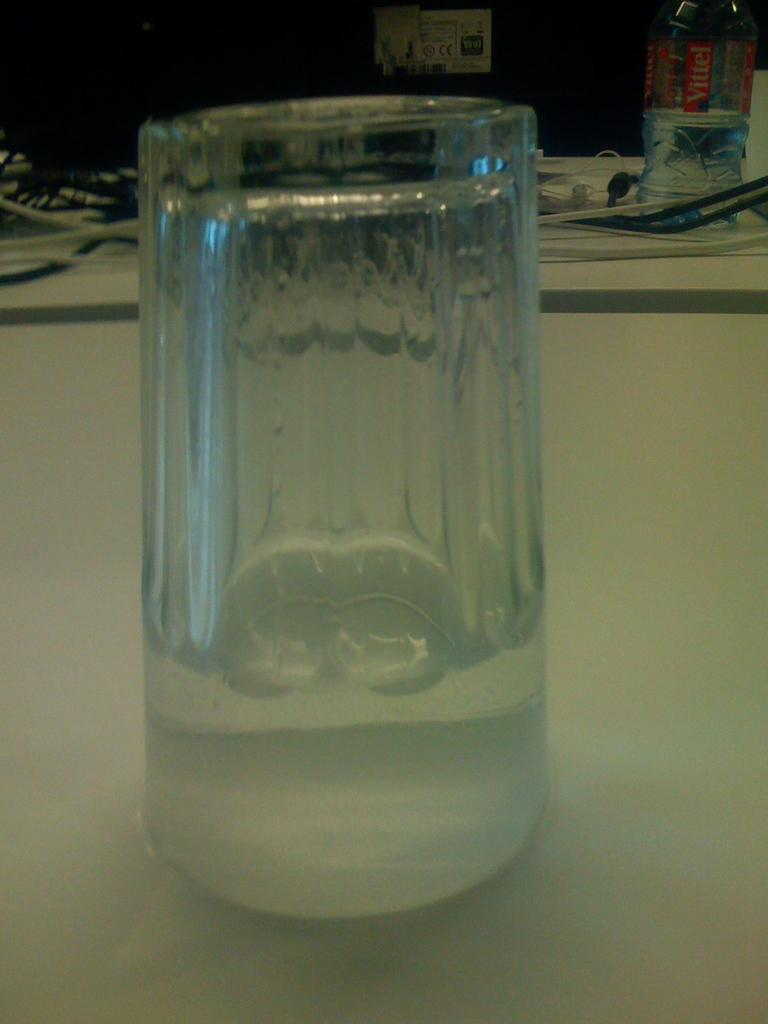What is the main object visible in the image? There is a glass in the image. Where is the bottle located in the image? The bottle is in the right top corner of the image. What else can be seen in the right top corner of the image? There are wires in the right top corner of the image. What is the plot of the story unfolding in the image? There is no story or plot present in the image, as it is a still image of objects. 